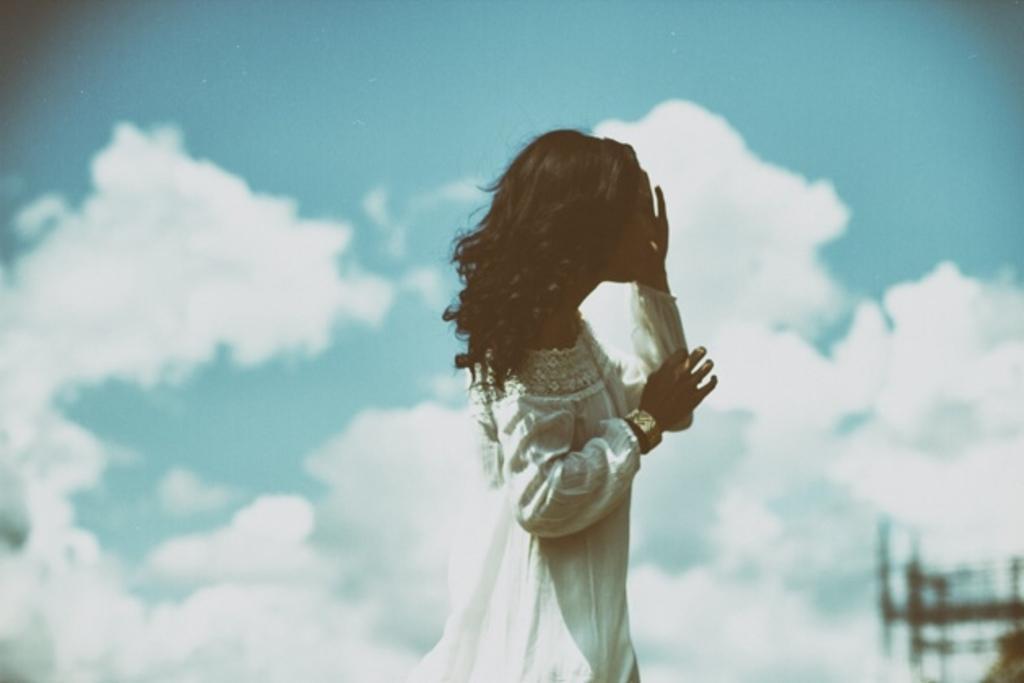Can you describe this image briefly? There is a lady wearing white dress and a bangle. In the background there is sky with clouds. 